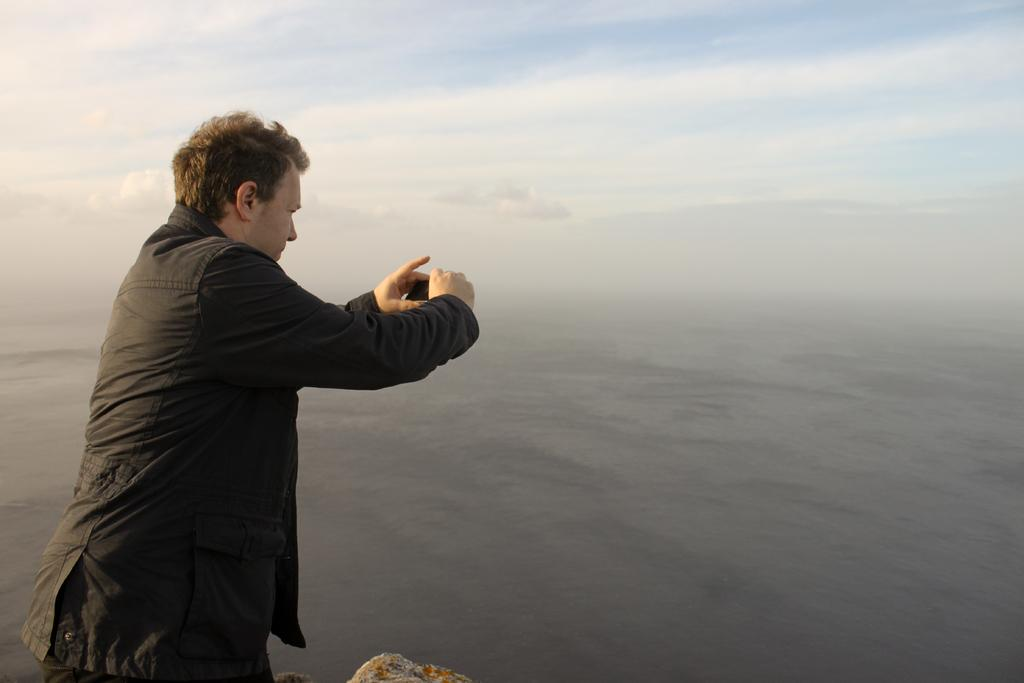What is the main subject of the image? There is a man in the image. What is the man doing in the image? The man is standing and holding a camera in his hands. What can be seen in the background of the image? There is sky and sea visible in the background of the image. What is the condition of the sky in the image? The sky has clouds in it. How many chickens are present in the image? There are no chickens present in the image. What type of cart is being used by the spy in the image? There is no spy or cart present in the image. 